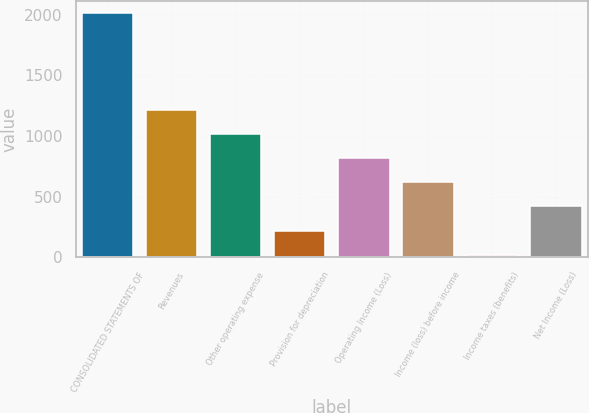Convert chart. <chart><loc_0><loc_0><loc_500><loc_500><bar_chart><fcel>CONSOLIDATED STATEMENTS OF<fcel>Revenues<fcel>Other operating expense<fcel>Provision for depreciation<fcel>Operating Income (Loss)<fcel>Income (loss) before income<fcel>Income taxes (benefits)<fcel>Net Income (Loss)<nl><fcel>2012<fcel>1215.6<fcel>1016.5<fcel>220.1<fcel>817.4<fcel>618.3<fcel>21<fcel>419.2<nl></chart> 